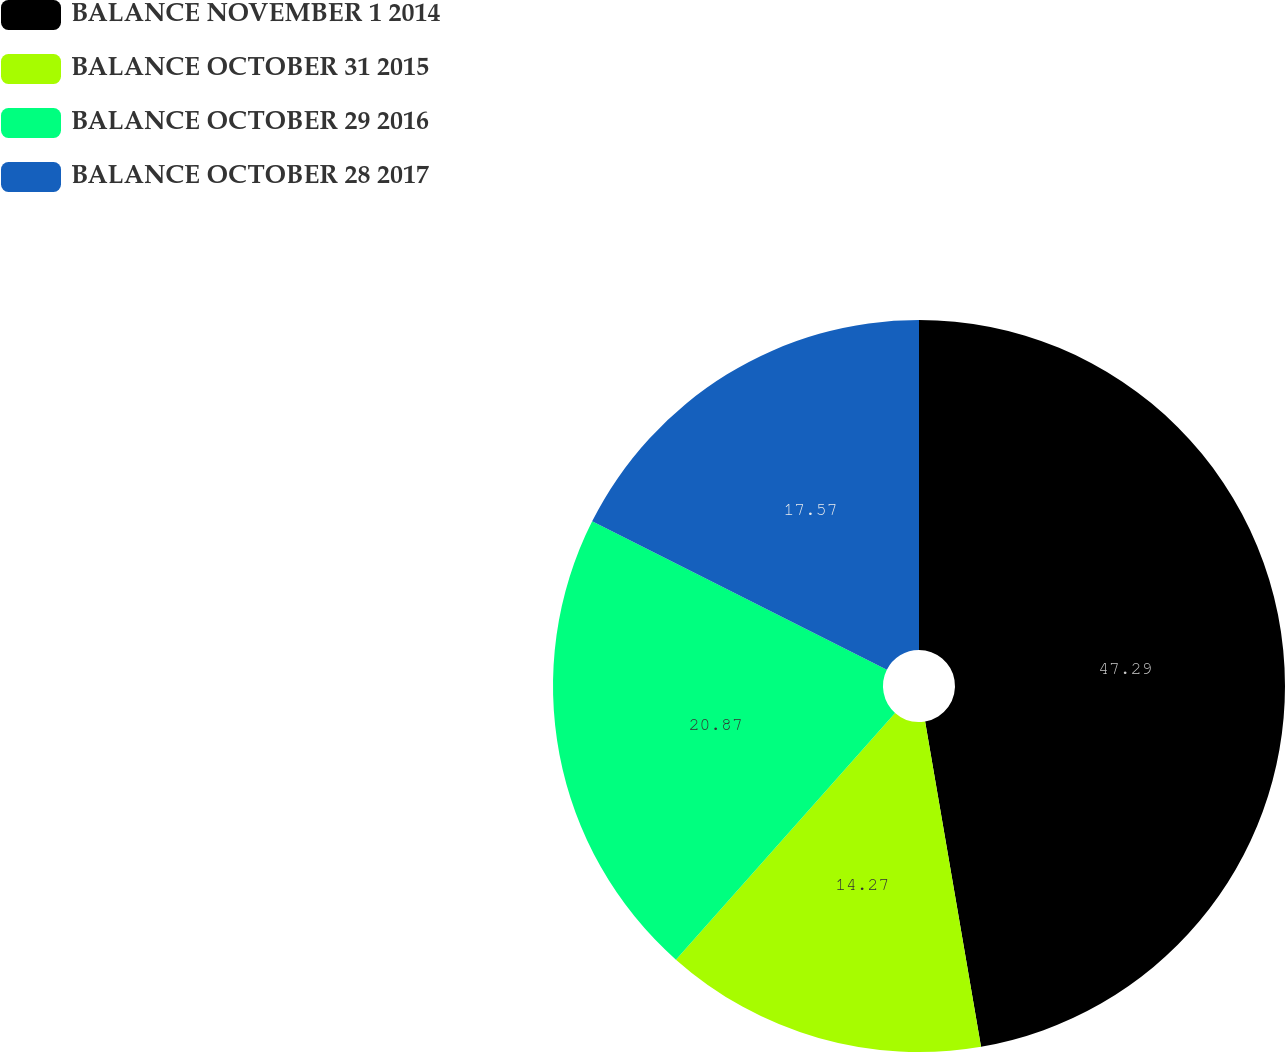<chart> <loc_0><loc_0><loc_500><loc_500><pie_chart><fcel>BALANCE NOVEMBER 1 2014<fcel>BALANCE OCTOBER 31 2015<fcel>BALANCE OCTOBER 29 2016<fcel>BALANCE OCTOBER 28 2017<nl><fcel>47.29%<fcel>14.27%<fcel>20.87%<fcel>17.57%<nl></chart> 